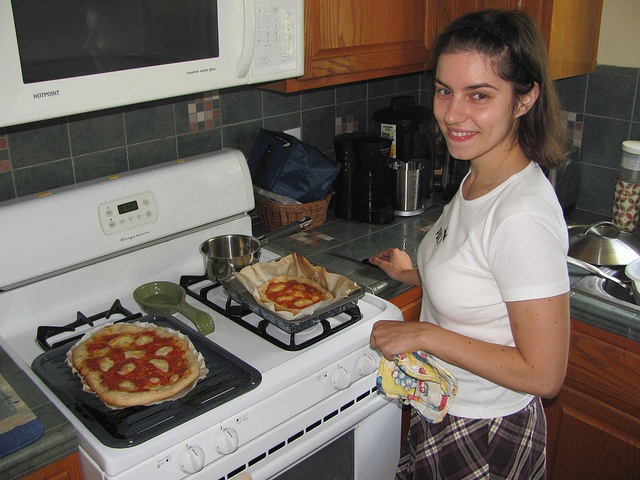Describe the objects in this image and their specific colors. I can see oven in darkgray, black, lightgray, and gray tones, people in darkgray, lightgray, gray, and black tones, microwave in darkgray, black, and lightgray tones, pizza in darkgray, maroon, olive, and tan tones, and pizza in darkgray, brown, maroon, and tan tones in this image. 